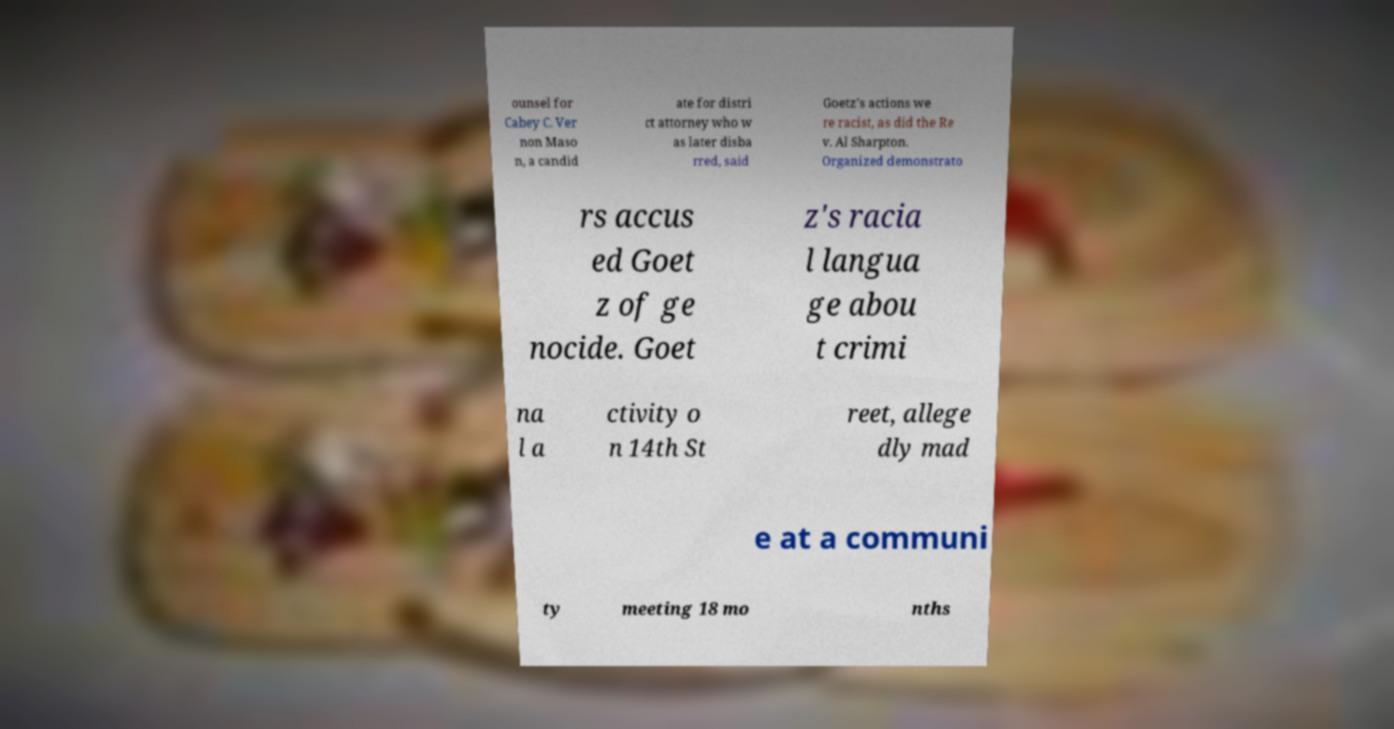Can you accurately transcribe the text from the provided image for me? ounsel for Cabey C. Ver non Maso n, a candid ate for distri ct attorney who w as later disba rred, said Goetz's actions we re racist, as did the Re v. Al Sharpton. Organized demonstrato rs accus ed Goet z of ge nocide. Goet z's racia l langua ge abou t crimi na l a ctivity o n 14th St reet, allege dly mad e at a communi ty meeting 18 mo nths 